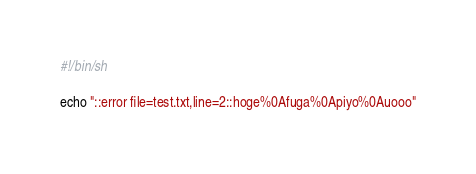Convert code to text. <code><loc_0><loc_0><loc_500><loc_500><_Bash_>#!/bin/sh

echo "::error file=test.txt,line=2::hoge%0Afuga%0Apiyo%0Auooo"
</code> 